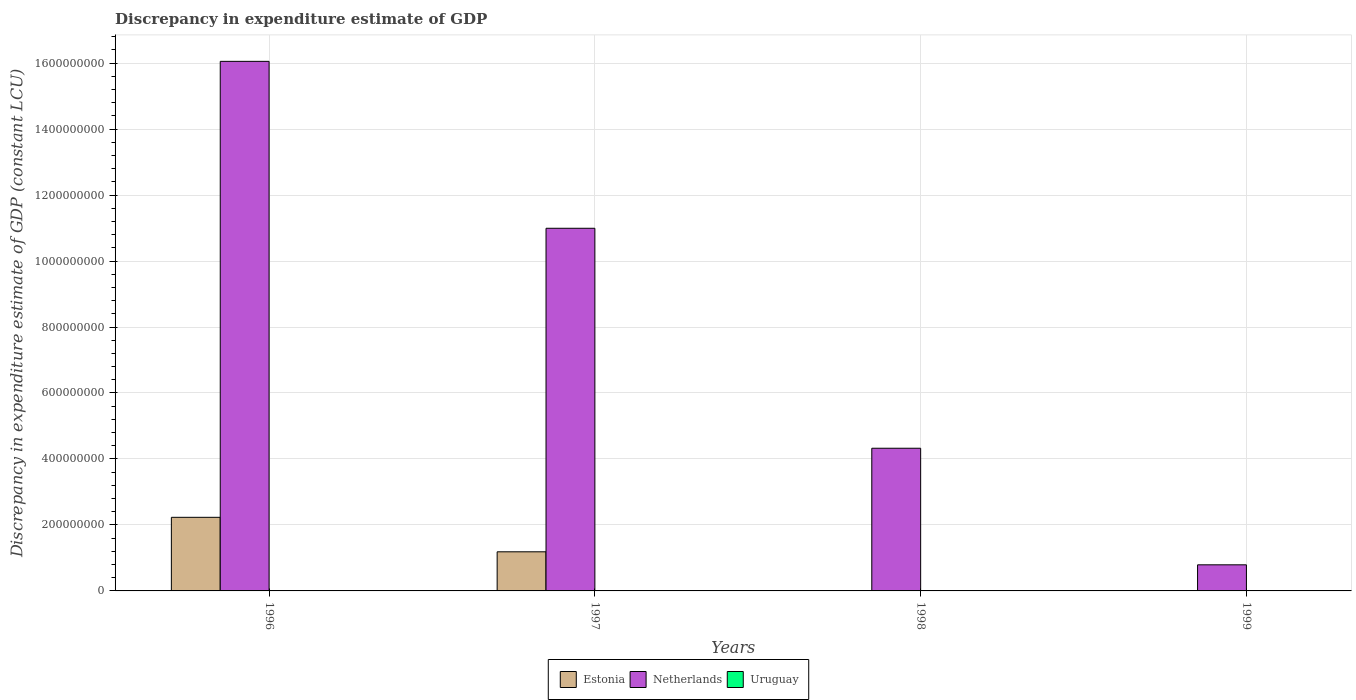What is the label of the 4th group of bars from the left?
Offer a terse response. 1999. In how many cases, is the number of bars for a given year not equal to the number of legend labels?
Provide a short and direct response. 4. What is the discrepancy in expenditure estimate of GDP in Uruguay in 1996?
Ensure brevity in your answer.  0. Across all years, what is the maximum discrepancy in expenditure estimate of GDP in Estonia?
Offer a terse response. 2.23e+08. In which year was the discrepancy in expenditure estimate of GDP in Estonia maximum?
Give a very brief answer. 1996. What is the total discrepancy in expenditure estimate of GDP in Netherlands in the graph?
Offer a terse response. 3.22e+09. What is the difference between the discrepancy in expenditure estimate of GDP in Netherlands in 1996 and that in 1997?
Your response must be concise. 5.06e+08. What is the difference between the discrepancy in expenditure estimate of GDP in Estonia in 1998 and the discrepancy in expenditure estimate of GDP in Uruguay in 1996?
Ensure brevity in your answer.  0. In the year 1996, what is the difference between the discrepancy in expenditure estimate of GDP in Estonia and discrepancy in expenditure estimate of GDP in Netherlands?
Make the answer very short. -1.38e+09. In how many years, is the discrepancy in expenditure estimate of GDP in Netherlands greater than 760000000 LCU?
Provide a short and direct response. 2. What is the ratio of the discrepancy in expenditure estimate of GDP in Netherlands in 1996 to that in 1999?
Your answer should be compact. 20.29. What is the difference between the highest and the lowest discrepancy in expenditure estimate of GDP in Netherlands?
Give a very brief answer. 1.53e+09. Is it the case that in every year, the sum of the discrepancy in expenditure estimate of GDP in Uruguay and discrepancy in expenditure estimate of GDP in Netherlands is greater than the discrepancy in expenditure estimate of GDP in Estonia?
Provide a short and direct response. Yes. How many bars are there?
Offer a very short reply. 6. Are all the bars in the graph horizontal?
Ensure brevity in your answer.  No. How many years are there in the graph?
Provide a succinct answer. 4. What is the difference between two consecutive major ticks on the Y-axis?
Your answer should be very brief. 2.00e+08. Are the values on the major ticks of Y-axis written in scientific E-notation?
Give a very brief answer. No. Does the graph contain any zero values?
Offer a terse response. Yes. Does the graph contain grids?
Your answer should be compact. Yes. Where does the legend appear in the graph?
Offer a terse response. Bottom center. How many legend labels are there?
Offer a very short reply. 3. What is the title of the graph?
Your answer should be compact. Discrepancy in expenditure estimate of GDP. What is the label or title of the X-axis?
Offer a very short reply. Years. What is the label or title of the Y-axis?
Make the answer very short. Discrepancy in expenditure estimate of GDP (constant LCU). What is the Discrepancy in expenditure estimate of GDP (constant LCU) of Estonia in 1996?
Keep it short and to the point. 2.23e+08. What is the Discrepancy in expenditure estimate of GDP (constant LCU) in Netherlands in 1996?
Give a very brief answer. 1.61e+09. What is the Discrepancy in expenditure estimate of GDP (constant LCU) of Uruguay in 1996?
Offer a very short reply. 0. What is the Discrepancy in expenditure estimate of GDP (constant LCU) of Estonia in 1997?
Provide a short and direct response. 1.19e+08. What is the Discrepancy in expenditure estimate of GDP (constant LCU) of Netherlands in 1997?
Your answer should be compact. 1.10e+09. What is the Discrepancy in expenditure estimate of GDP (constant LCU) of Uruguay in 1997?
Give a very brief answer. 0. What is the Discrepancy in expenditure estimate of GDP (constant LCU) of Netherlands in 1998?
Make the answer very short. 4.32e+08. What is the Discrepancy in expenditure estimate of GDP (constant LCU) in Uruguay in 1998?
Keep it short and to the point. 0. What is the Discrepancy in expenditure estimate of GDP (constant LCU) of Estonia in 1999?
Your response must be concise. 0. What is the Discrepancy in expenditure estimate of GDP (constant LCU) in Netherlands in 1999?
Provide a succinct answer. 7.91e+07. What is the Discrepancy in expenditure estimate of GDP (constant LCU) in Uruguay in 1999?
Give a very brief answer. 0. Across all years, what is the maximum Discrepancy in expenditure estimate of GDP (constant LCU) in Estonia?
Give a very brief answer. 2.23e+08. Across all years, what is the maximum Discrepancy in expenditure estimate of GDP (constant LCU) of Netherlands?
Your answer should be compact. 1.61e+09. Across all years, what is the minimum Discrepancy in expenditure estimate of GDP (constant LCU) of Netherlands?
Your answer should be compact. 7.91e+07. What is the total Discrepancy in expenditure estimate of GDP (constant LCU) of Estonia in the graph?
Provide a succinct answer. 3.42e+08. What is the total Discrepancy in expenditure estimate of GDP (constant LCU) of Netherlands in the graph?
Give a very brief answer. 3.22e+09. What is the difference between the Discrepancy in expenditure estimate of GDP (constant LCU) of Estonia in 1996 and that in 1997?
Offer a very short reply. 1.05e+08. What is the difference between the Discrepancy in expenditure estimate of GDP (constant LCU) in Netherlands in 1996 and that in 1997?
Provide a short and direct response. 5.06e+08. What is the difference between the Discrepancy in expenditure estimate of GDP (constant LCU) in Netherlands in 1996 and that in 1998?
Offer a very short reply. 1.17e+09. What is the difference between the Discrepancy in expenditure estimate of GDP (constant LCU) in Netherlands in 1996 and that in 1999?
Your answer should be very brief. 1.53e+09. What is the difference between the Discrepancy in expenditure estimate of GDP (constant LCU) in Netherlands in 1997 and that in 1998?
Offer a terse response. 6.67e+08. What is the difference between the Discrepancy in expenditure estimate of GDP (constant LCU) of Netherlands in 1997 and that in 1999?
Your answer should be very brief. 1.02e+09. What is the difference between the Discrepancy in expenditure estimate of GDP (constant LCU) in Netherlands in 1998 and that in 1999?
Keep it short and to the point. 3.53e+08. What is the difference between the Discrepancy in expenditure estimate of GDP (constant LCU) of Estonia in 1996 and the Discrepancy in expenditure estimate of GDP (constant LCU) of Netherlands in 1997?
Offer a very short reply. -8.76e+08. What is the difference between the Discrepancy in expenditure estimate of GDP (constant LCU) of Estonia in 1996 and the Discrepancy in expenditure estimate of GDP (constant LCU) of Netherlands in 1998?
Your answer should be very brief. -2.09e+08. What is the difference between the Discrepancy in expenditure estimate of GDP (constant LCU) of Estonia in 1996 and the Discrepancy in expenditure estimate of GDP (constant LCU) of Netherlands in 1999?
Your answer should be compact. 1.44e+08. What is the difference between the Discrepancy in expenditure estimate of GDP (constant LCU) of Estonia in 1997 and the Discrepancy in expenditure estimate of GDP (constant LCU) of Netherlands in 1998?
Offer a very short reply. -3.14e+08. What is the difference between the Discrepancy in expenditure estimate of GDP (constant LCU) of Estonia in 1997 and the Discrepancy in expenditure estimate of GDP (constant LCU) of Netherlands in 1999?
Provide a succinct answer. 3.95e+07. What is the average Discrepancy in expenditure estimate of GDP (constant LCU) of Estonia per year?
Offer a terse response. 8.54e+07. What is the average Discrepancy in expenditure estimate of GDP (constant LCU) of Netherlands per year?
Your answer should be very brief. 8.04e+08. What is the average Discrepancy in expenditure estimate of GDP (constant LCU) of Uruguay per year?
Offer a very short reply. 0. In the year 1996, what is the difference between the Discrepancy in expenditure estimate of GDP (constant LCU) of Estonia and Discrepancy in expenditure estimate of GDP (constant LCU) of Netherlands?
Your response must be concise. -1.38e+09. In the year 1997, what is the difference between the Discrepancy in expenditure estimate of GDP (constant LCU) of Estonia and Discrepancy in expenditure estimate of GDP (constant LCU) of Netherlands?
Ensure brevity in your answer.  -9.81e+08. What is the ratio of the Discrepancy in expenditure estimate of GDP (constant LCU) of Estonia in 1996 to that in 1997?
Offer a terse response. 1.88. What is the ratio of the Discrepancy in expenditure estimate of GDP (constant LCU) of Netherlands in 1996 to that in 1997?
Your answer should be very brief. 1.46. What is the ratio of the Discrepancy in expenditure estimate of GDP (constant LCU) of Netherlands in 1996 to that in 1998?
Provide a short and direct response. 3.71. What is the ratio of the Discrepancy in expenditure estimate of GDP (constant LCU) in Netherlands in 1996 to that in 1999?
Keep it short and to the point. 20.29. What is the ratio of the Discrepancy in expenditure estimate of GDP (constant LCU) of Netherlands in 1997 to that in 1998?
Provide a short and direct response. 2.54. What is the ratio of the Discrepancy in expenditure estimate of GDP (constant LCU) of Netherlands in 1997 to that in 1999?
Ensure brevity in your answer.  13.89. What is the ratio of the Discrepancy in expenditure estimate of GDP (constant LCU) in Netherlands in 1998 to that in 1999?
Offer a terse response. 5.47. What is the difference between the highest and the second highest Discrepancy in expenditure estimate of GDP (constant LCU) in Netherlands?
Your answer should be very brief. 5.06e+08. What is the difference between the highest and the lowest Discrepancy in expenditure estimate of GDP (constant LCU) of Estonia?
Offer a terse response. 2.23e+08. What is the difference between the highest and the lowest Discrepancy in expenditure estimate of GDP (constant LCU) in Netherlands?
Your answer should be very brief. 1.53e+09. 